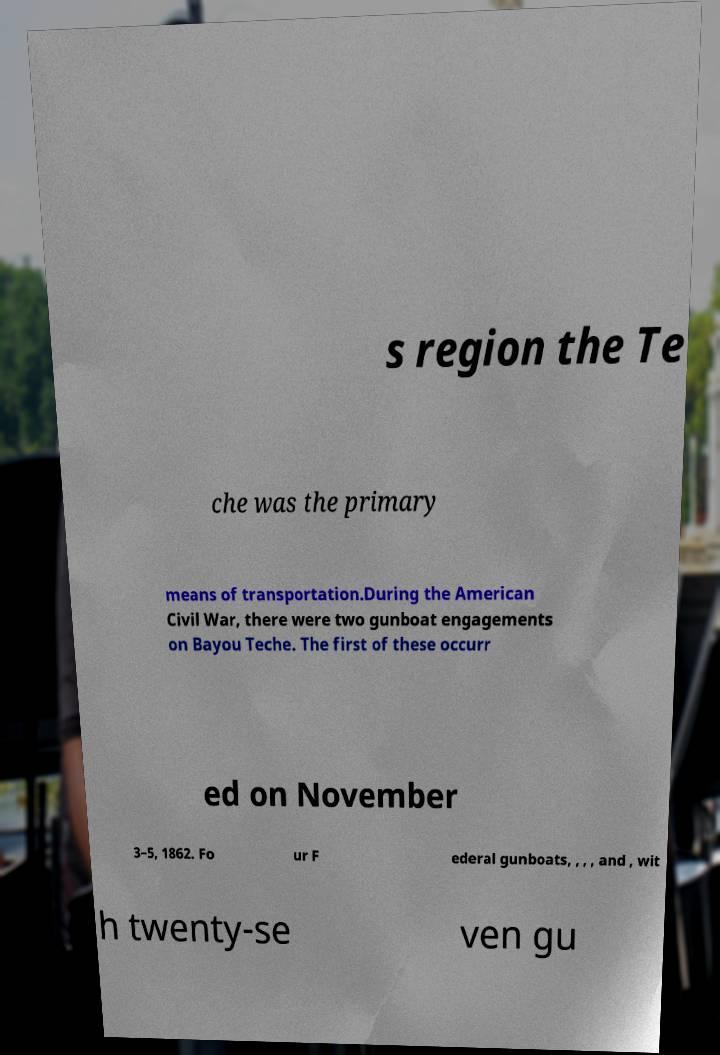Could you extract and type out the text from this image? s region the Te che was the primary means of transportation.During the American Civil War, there were two gunboat engagements on Bayou Teche. The first of these occurr ed on November 3–5, 1862. Fo ur F ederal gunboats, , , , and , wit h twenty-se ven gu 